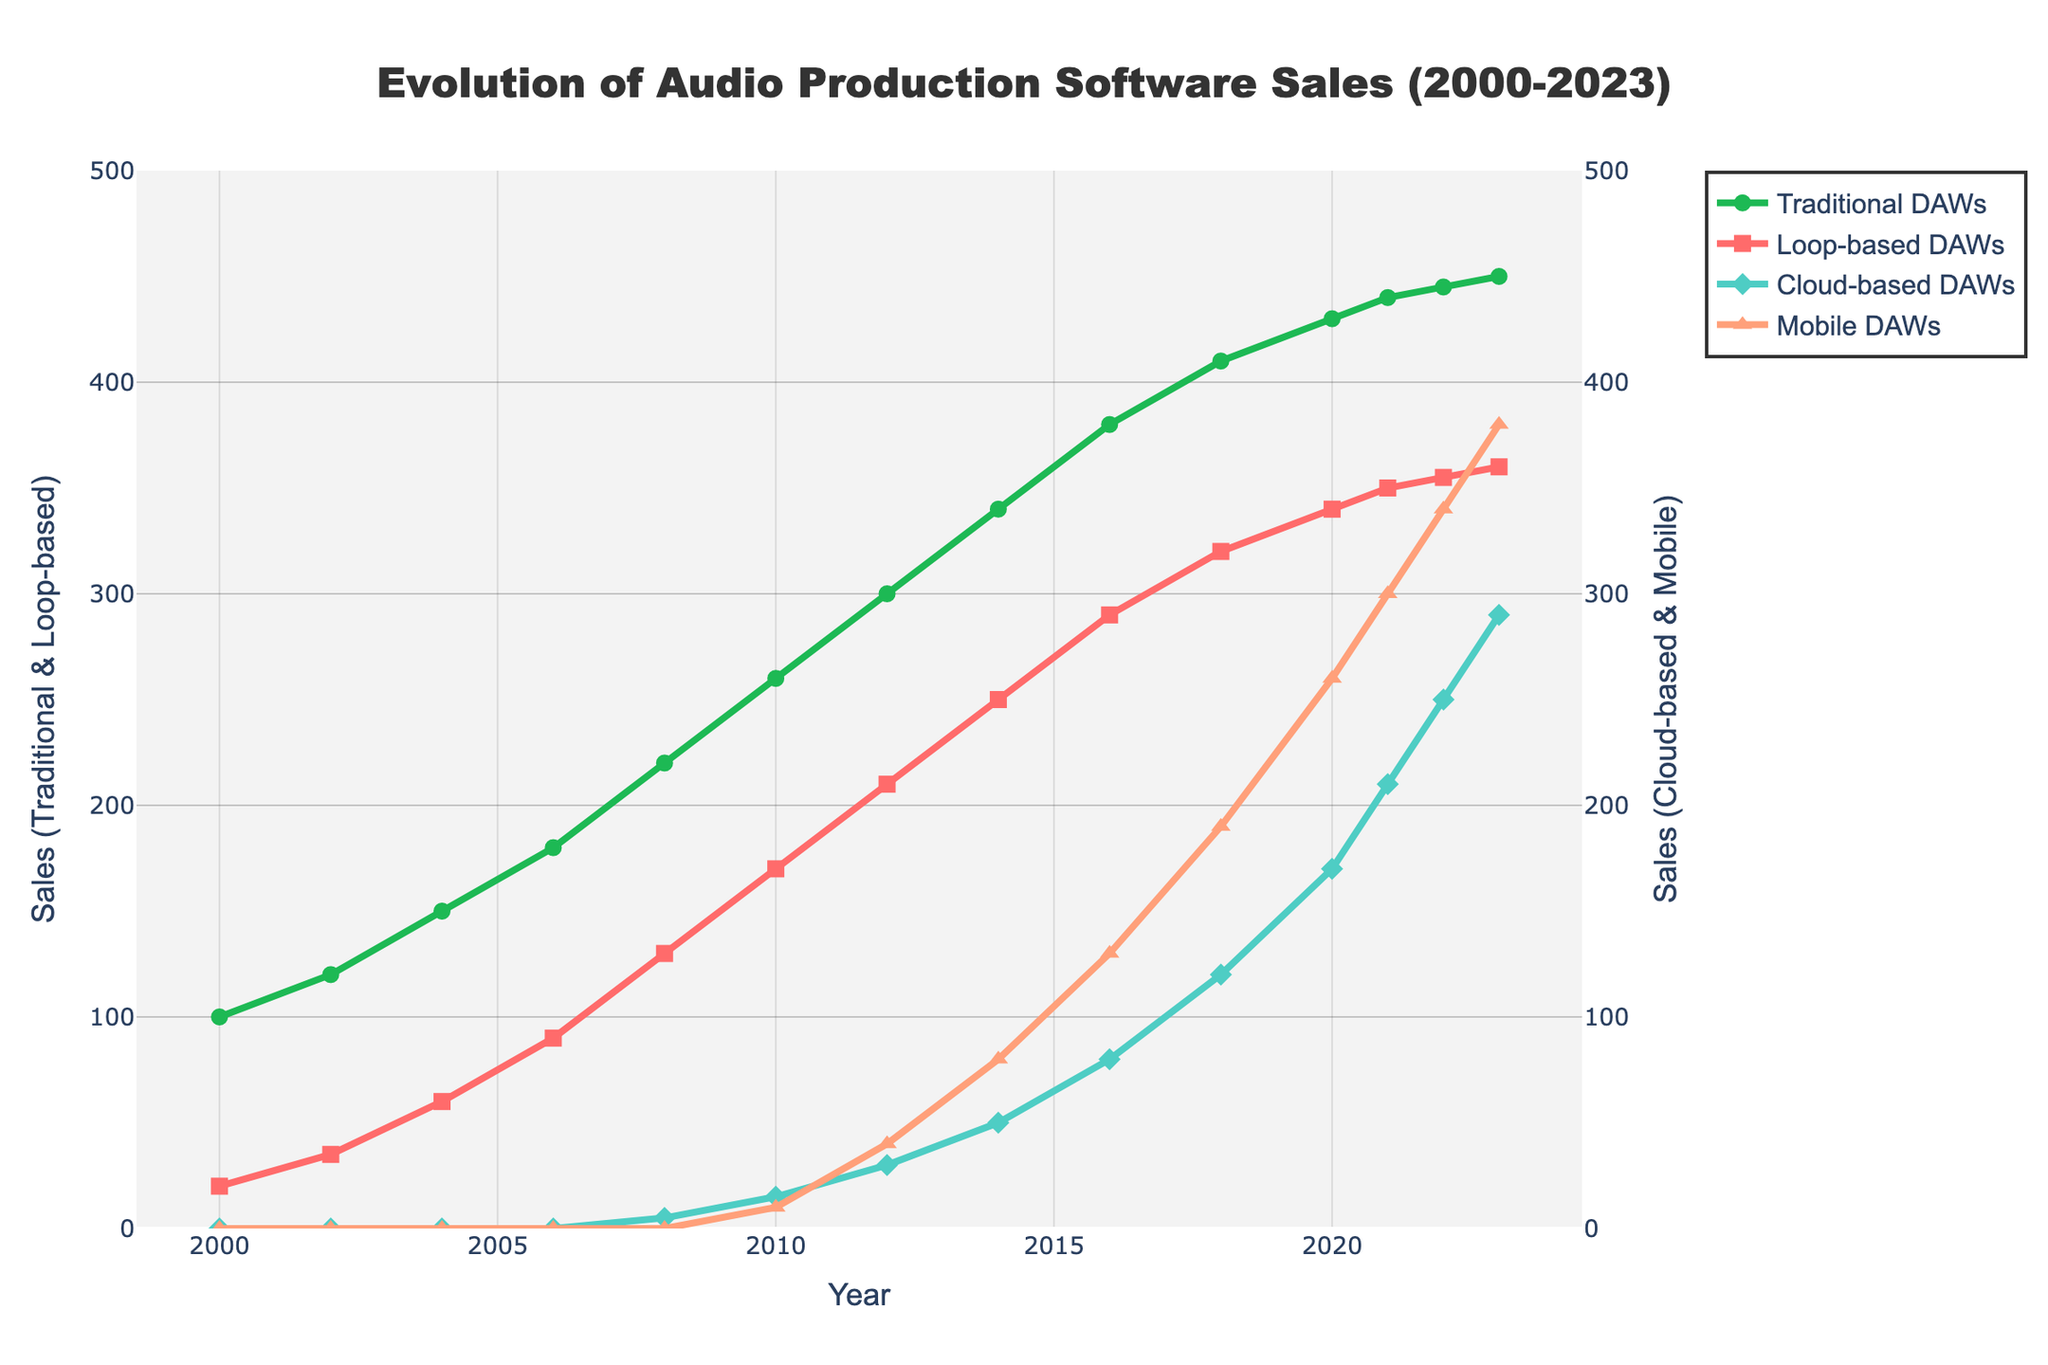What is the sales trend of Traditional DAWs from 2000 to 2023? The sales of Traditional DAWs have increased consistently over the years as indicated by the rising green line. Starting from 100 in 2000 and gradually climbing each year, reaching 450 in 2023.
Answer: Increasing consistently Which year did Loop-based DAWs first surpass 100 in sales? Loop-based DAWs passed 100 in 2006, illustrated by the red line crossing the 100 mark between 2004 and 2008.
Answer: 2006 In 2010, what is the difference in sales between Cloud-based DAWs and Mobile DAWs? In 2010, Cloud-based DAWs had sales of 15 while Mobile DAWs had sales of 10. The difference is 15 - 10 = 5.
Answer: 5 Compare the sales growth of Mobile DAWs and Cloud-based DAWs from 2018 to 2023. From 2018 to 2023, Mobile DAWs grew from 190 to 380, an increase of 380 - 190 = 190. Cloud-based DAWs grew from 120 to 290, an increase of 290 - 120 = 170. Mobile DAWs had a higher growth rate.
Answer: Mobile DAWs had higher growth What is the total sales of all DAW types in 2023? Add the sales of each DAW type in 2023: 450 (Traditional) + 360 (Loop-based) + 290 (Cloud-based) + 380 (Mobile). The total is 450 + 360 + 290 + 380 = 1480.
Answer: 1480 Which DAW type showed the maximum increase in sales between any two successive years? To find the maximum increase, observe the largest vertical jump in any line. Cloud-based DAWs showed a jump from 170 to 210 between 2020 and 2021, an increase of 40.
Answer: Cloud-based DAWs, 2020-2021 Identify the year with the highest combined sales for Traditional and Loop-based DAWs. By observing the green and red lines on the left y-axis, 2023 has the highest combined value: 450 (Traditional) + 360 (Loop-based) = 810.
Answer: 2023 Which DAW type had the slowest growth rate from 2000 to 2023? By checking the steepness of lines: The green line (Traditional DAWs) starts at 100 and ends at 450, representing steady growth. The Loop-based red line shows considerable growth. Cloud-based (teal) and Mobile (orange) both show rapid increase after 2008 and 2010 respectively. As the green line is most consistent and least steep (excluding periods of rapid growth in new DAWs), the Traditional DAWs had the slowest rate.
Answer: Traditional DAWs What is the average sales of Loop-based DAWs over the given period? Sum all given sales data for Loop-based DAWs: 20 + 35 + 60 + 90 + 130 + 170 + 210 + 250 + 290 + 320 + 340 + 350 + 355 + 360 = 2990. There are 14 years, so the average is 2990 / 14.
Answer: 213.57 